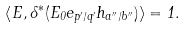<formula> <loc_0><loc_0><loc_500><loc_500>\left \langle E , \delta ^ { * } ( E _ { 0 } e _ { p ^ { \prime } / q ^ { \prime } } h _ { a ^ { \prime \prime } / b ^ { \prime \prime } } ) \right \rangle = 1 .</formula> 